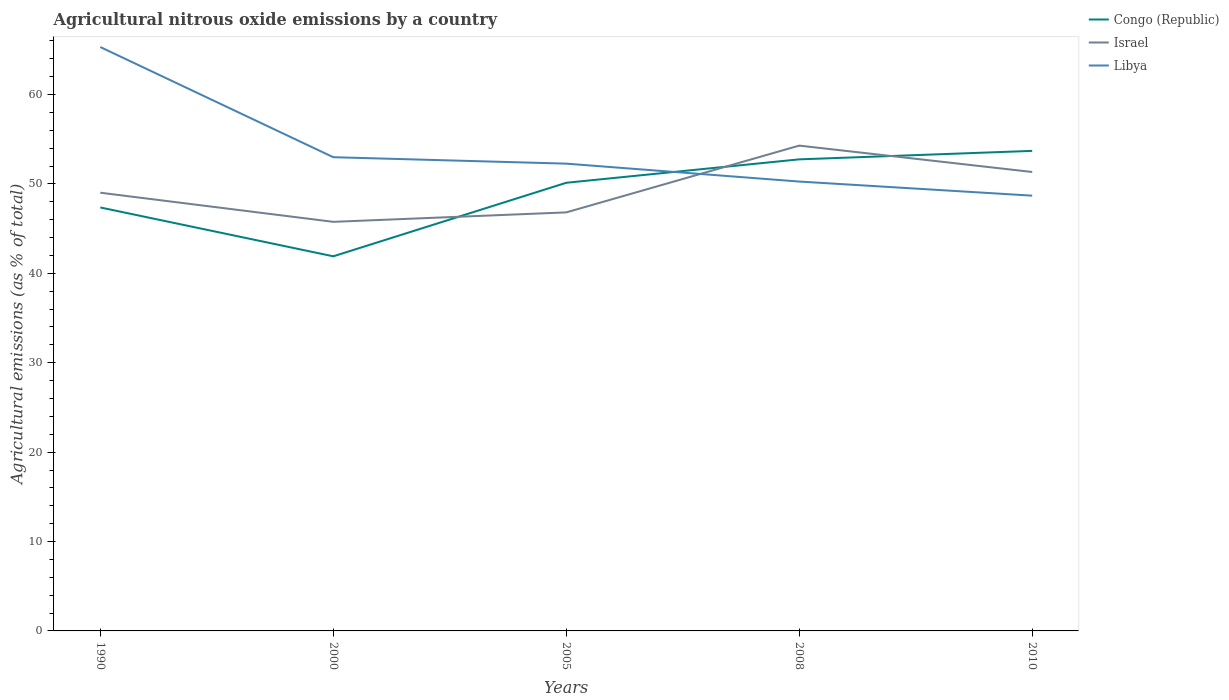How many different coloured lines are there?
Your response must be concise. 3. Does the line corresponding to Congo (Republic) intersect with the line corresponding to Israel?
Your answer should be compact. Yes. Across all years, what is the maximum amount of agricultural nitrous oxide emitted in Libya?
Your response must be concise. 48.69. What is the total amount of agricultural nitrous oxide emitted in Libya in the graph?
Provide a succinct answer. 3.58. What is the difference between the highest and the second highest amount of agricultural nitrous oxide emitted in Libya?
Provide a succinct answer. 16.62. What is the difference between the highest and the lowest amount of agricultural nitrous oxide emitted in Congo (Republic)?
Offer a very short reply. 3. Is the amount of agricultural nitrous oxide emitted in Congo (Republic) strictly greater than the amount of agricultural nitrous oxide emitted in Libya over the years?
Ensure brevity in your answer.  No. How many years are there in the graph?
Provide a short and direct response. 5. What is the difference between two consecutive major ticks on the Y-axis?
Your response must be concise. 10. Are the values on the major ticks of Y-axis written in scientific E-notation?
Provide a succinct answer. No. What is the title of the graph?
Provide a short and direct response. Agricultural nitrous oxide emissions by a country. Does "Northern Mariana Islands" appear as one of the legend labels in the graph?
Offer a terse response. No. What is the label or title of the X-axis?
Offer a very short reply. Years. What is the label or title of the Y-axis?
Offer a very short reply. Agricultural emissions (as % of total). What is the Agricultural emissions (as % of total) in Congo (Republic) in 1990?
Make the answer very short. 47.37. What is the Agricultural emissions (as % of total) in Israel in 1990?
Make the answer very short. 49.02. What is the Agricultural emissions (as % of total) of Libya in 1990?
Your response must be concise. 65.31. What is the Agricultural emissions (as % of total) in Congo (Republic) in 2000?
Your response must be concise. 41.9. What is the Agricultural emissions (as % of total) of Israel in 2000?
Make the answer very short. 45.76. What is the Agricultural emissions (as % of total) of Libya in 2000?
Give a very brief answer. 52.99. What is the Agricultural emissions (as % of total) of Congo (Republic) in 2005?
Give a very brief answer. 50.13. What is the Agricultural emissions (as % of total) in Israel in 2005?
Ensure brevity in your answer.  46.82. What is the Agricultural emissions (as % of total) in Libya in 2005?
Offer a terse response. 52.27. What is the Agricultural emissions (as % of total) in Congo (Republic) in 2008?
Provide a succinct answer. 52.75. What is the Agricultural emissions (as % of total) in Israel in 2008?
Keep it short and to the point. 54.29. What is the Agricultural emissions (as % of total) of Libya in 2008?
Make the answer very short. 50.27. What is the Agricultural emissions (as % of total) in Congo (Republic) in 2010?
Your response must be concise. 53.7. What is the Agricultural emissions (as % of total) of Israel in 2010?
Ensure brevity in your answer.  51.34. What is the Agricultural emissions (as % of total) in Libya in 2010?
Your answer should be compact. 48.69. Across all years, what is the maximum Agricultural emissions (as % of total) in Congo (Republic)?
Provide a succinct answer. 53.7. Across all years, what is the maximum Agricultural emissions (as % of total) of Israel?
Offer a very short reply. 54.29. Across all years, what is the maximum Agricultural emissions (as % of total) of Libya?
Give a very brief answer. 65.31. Across all years, what is the minimum Agricultural emissions (as % of total) of Congo (Republic)?
Your answer should be very brief. 41.9. Across all years, what is the minimum Agricultural emissions (as % of total) of Israel?
Provide a succinct answer. 45.76. Across all years, what is the minimum Agricultural emissions (as % of total) in Libya?
Offer a very short reply. 48.69. What is the total Agricultural emissions (as % of total) in Congo (Republic) in the graph?
Your answer should be compact. 245.85. What is the total Agricultural emissions (as % of total) of Israel in the graph?
Give a very brief answer. 247.22. What is the total Agricultural emissions (as % of total) in Libya in the graph?
Provide a succinct answer. 269.53. What is the difference between the Agricultural emissions (as % of total) of Congo (Republic) in 1990 and that in 2000?
Provide a succinct answer. 5.46. What is the difference between the Agricultural emissions (as % of total) of Israel in 1990 and that in 2000?
Ensure brevity in your answer.  3.26. What is the difference between the Agricultural emissions (as % of total) of Libya in 1990 and that in 2000?
Your response must be concise. 12.32. What is the difference between the Agricultural emissions (as % of total) in Congo (Republic) in 1990 and that in 2005?
Keep it short and to the point. -2.76. What is the difference between the Agricultural emissions (as % of total) of Israel in 1990 and that in 2005?
Provide a succinct answer. 2.2. What is the difference between the Agricultural emissions (as % of total) in Libya in 1990 and that in 2005?
Your response must be concise. 13.04. What is the difference between the Agricultural emissions (as % of total) in Congo (Republic) in 1990 and that in 2008?
Make the answer very short. -5.38. What is the difference between the Agricultural emissions (as % of total) in Israel in 1990 and that in 2008?
Provide a short and direct response. -5.27. What is the difference between the Agricultural emissions (as % of total) of Libya in 1990 and that in 2008?
Your answer should be compact. 15.05. What is the difference between the Agricultural emissions (as % of total) of Congo (Republic) in 1990 and that in 2010?
Give a very brief answer. -6.33. What is the difference between the Agricultural emissions (as % of total) of Israel in 1990 and that in 2010?
Make the answer very short. -2.32. What is the difference between the Agricultural emissions (as % of total) of Libya in 1990 and that in 2010?
Ensure brevity in your answer.  16.62. What is the difference between the Agricultural emissions (as % of total) in Congo (Republic) in 2000 and that in 2005?
Provide a succinct answer. -8.23. What is the difference between the Agricultural emissions (as % of total) of Israel in 2000 and that in 2005?
Give a very brief answer. -1.06. What is the difference between the Agricultural emissions (as % of total) in Libya in 2000 and that in 2005?
Keep it short and to the point. 0.72. What is the difference between the Agricultural emissions (as % of total) of Congo (Republic) in 2000 and that in 2008?
Your answer should be compact. -10.84. What is the difference between the Agricultural emissions (as % of total) in Israel in 2000 and that in 2008?
Your response must be concise. -8.53. What is the difference between the Agricultural emissions (as % of total) in Libya in 2000 and that in 2008?
Your answer should be compact. 2.72. What is the difference between the Agricultural emissions (as % of total) in Congo (Republic) in 2000 and that in 2010?
Offer a very short reply. -11.79. What is the difference between the Agricultural emissions (as % of total) in Israel in 2000 and that in 2010?
Give a very brief answer. -5.58. What is the difference between the Agricultural emissions (as % of total) in Libya in 2000 and that in 2010?
Make the answer very short. 4.3. What is the difference between the Agricultural emissions (as % of total) of Congo (Republic) in 2005 and that in 2008?
Offer a terse response. -2.62. What is the difference between the Agricultural emissions (as % of total) in Israel in 2005 and that in 2008?
Offer a very short reply. -7.47. What is the difference between the Agricultural emissions (as % of total) of Libya in 2005 and that in 2008?
Give a very brief answer. 2. What is the difference between the Agricultural emissions (as % of total) of Congo (Republic) in 2005 and that in 2010?
Offer a terse response. -3.57. What is the difference between the Agricultural emissions (as % of total) of Israel in 2005 and that in 2010?
Ensure brevity in your answer.  -4.52. What is the difference between the Agricultural emissions (as % of total) of Libya in 2005 and that in 2010?
Ensure brevity in your answer.  3.58. What is the difference between the Agricultural emissions (as % of total) in Congo (Republic) in 2008 and that in 2010?
Offer a very short reply. -0.95. What is the difference between the Agricultural emissions (as % of total) in Israel in 2008 and that in 2010?
Give a very brief answer. 2.95. What is the difference between the Agricultural emissions (as % of total) in Libya in 2008 and that in 2010?
Your answer should be compact. 1.58. What is the difference between the Agricultural emissions (as % of total) of Congo (Republic) in 1990 and the Agricultural emissions (as % of total) of Israel in 2000?
Offer a very short reply. 1.61. What is the difference between the Agricultural emissions (as % of total) of Congo (Republic) in 1990 and the Agricultural emissions (as % of total) of Libya in 2000?
Give a very brief answer. -5.62. What is the difference between the Agricultural emissions (as % of total) of Israel in 1990 and the Agricultural emissions (as % of total) of Libya in 2000?
Provide a short and direct response. -3.97. What is the difference between the Agricultural emissions (as % of total) of Congo (Republic) in 1990 and the Agricultural emissions (as % of total) of Israel in 2005?
Offer a terse response. 0.55. What is the difference between the Agricultural emissions (as % of total) of Congo (Republic) in 1990 and the Agricultural emissions (as % of total) of Libya in 2005?
Offer a very short reply. -4.9. What is the difference between the Agricultural emissions (as % of total) in Israel in 1990 and the Agricultural emissions (as % of total) in Libya in 2005?
Keep it short and to the point. -3.25. What is the difference between the Agricultural emissions (as % of total) of Congo (Republic) in 1990 and the Agricultural emissions (as % of total) of Israel in 2008?
Provide a short and direct response. -6.92. What is the difference between the Agricultural emissions (as % of total) in Congo (Republic) in 1990 and the Agricultural emissions (as % of total) in Libya in 2008?
Ensure brevity in your answer.  -2.9. What is the difference between the Agricultural emissions (as % of total) in Israel in 1990 and the Agricultural emissions (as % of total) in Libya in 2008?
Your response must be concise. -1.25. What is the difference between the Agricultural emissions (as % of total) in Congo (Republic) in 1990 and the Agricultural emissions (as % of total) in Israel in 2010?
Keep it short and to the point. -3.97. What is the difference between the Agricultural emissions (as % of total) of Congo (Republic) in 1990 and the Agricultural emissions (as % of total) of Libya in 2010?
Keep it short and to the point. -1.32. What is the difference between the Agricultural emissions (as % of total) of Israel in 1990 and the Agricultural emissions (as % of total) of Libya in 2010?
Ensure brevity in your answer.  0.33. What is the difference between the Agricultural emissions (as % of total) of Congo (Republic) in 2000 and the Agricultural emissions (as % of total) of Israel in 2005?
Provide a short and direct response. -4.91. What is the difference between the Agricultural emissions (as % of total) in Congo (Republic) in 2000 and the Agricultural emissions (as % of total) in Libya in 2005?
Make the answer very short. -10.37. What is the difference between the Agricultural emissions (as % of total) in Israel in 2000 and the Agricultural emissions (as % of total) in Libya in 2005?
Ensure brevity in your answer.  -6.51. What is the difference between the Agricultural emissions (as % of total) of Congo (Republic) in 2000 and the Agricultural emissions (as % of total) of Israel in 2008?
Make the answer very short. -12.38. What is the difference between the Agricultural emissions (as % of total) of Congo (Republic) in 2000 and the Agricultural emissions (as % of total) of Libya in 2008?
Your answer should be very brief. -8.36. What is the difference between the Agricultural emissions (as % of total) of Israel in 2000 and the Agricultural emissions (as % of total) of Libya in 2008?
Keep it short and to the point. -4.51. What is the difference between the Agricultural emissions (as % of total) in Congo (Republic) in 2000 and the Agricultural emissions (as % of total) in Israel in 2010?
Keep it short and to the point. -9.43. What is the difference between the Agricultural emissions (as % of total) in Congo (Republic) in 2000 and the Agricultural emissions (as % of total) in Libya in 2010?
Keep it short and to the point. -6.78. What is the difference between the Agricultural emissions (as % of total) in Israel in 2000 and the Agricultural emissions (as % of total) in Libya in 2010?
Ensure brevity in your answer.  -2.93. What is the difference between the Agricultural emissions (as % of total) in Congo (Republic) in 2005 and the Agricultural emissions (as % of total) in Israel in 2008?
Give a very brief answer. -4.16. What is the difference between the Agricultural emissions (as % of total) in Congo (Republic) in 2005 and the Agricultural emissions (as % of total) in Libya in 2008?
Offer a very short reply. -0.14. What is the difference between the Agricultural emissions (as % of total) in Israel in 2005 and the Agricultural emissions (as % of total) in Libya in 2008?
Provide a short and direct response. -3.45. What is the difference between the Agricultural emissions (as % of total) in Congo (Republic) in 2005 and the Agricultural emissions (as % of total) in Israel in 2010?
Give a very brief answer. -1.21. What is the difference between the Agricultural emissions (as % of total) in Congo (Republic) in 2005 and the Agricultural emissions (as % of total) in Libya in 2010?
Give a very brief answer. 1.44. What is the difference between the Agricultural emissions (as % of total) of Israel in 2005 and the Agricultural emissions (as % of total) of Libya in 2010?
Ensure brevity in your answer.  -1.87. What is the difference between the Agricultural emissions (as % of total) of Congo (Republic) in 2008 and the Agricultural emissions (as % of total) of Israel in 2010?
Offer a very short reply. 1.41. What is the difference between the Agricultural emissions (as % of total) of Congo (Republic) in 2008 and the Agricultural emissions (as % of total) of Libya in 2010?
Keep it short and to the point. 4.06. What is the difference between the Agricultural emissions (as % of total) of Israel in 2008 and the Agricultural emissions (as % of total) of Libya in 2010?
Your answer should be very brief. 5.6. What is the average Agricultural emissions (as % of total) in Congo (Republic) per year?
Your answer should be compact. 49.17. What is the average Agricultural emissions (as % of total) of Israel per year?
Offer a terse response. 49.44. What is the average Agricultural emissions (as % of total) of Libya per year?
Ensure brevity in your answer.  53.91. In the year 1990, what is the difference between the Agricultural emissions (as % of total) of Congo (Republic) and Agricultural emissions (as % of total) of Israel?
Offer a terse response. -1.65. In the year 1990, what is the difference between the Agricultural emissions (as % of total) in Congo (Republic) and Agricultural emissions (as % of total) in Libya?
Offer a terse response. -17.94. In the year 1990, what is the difference between the Agricultural emissions (as % of total) of Israel and Agricultural emissions (as % of total) of Libya?
Your answer should be compact. -16.29. In the year 2000, what is the difference between the Agricultural emissions (as % of total) of Congo (Republic) and Agricultural emissions (as % of total) of Israel?
Offer a terse response. -3.86. In the year 2000, what is the difference between the Agricultural emissions (as % of total) of Congo (Republic) and Agricultural emissions (as % of total) of Libya?
Keep it short and to the point. -11.09. In the year 2000, what is the difference between the Agricultural emissions (as % of total) in Israel and Agricultural emissions (as % of total) in Libya?
Provide a short and direct response. -7.23. In the year 2005, what is the difference between the Agricultural emissions (as % of total) in Congo (Republic) and Agricultural emissions (as % of total) in Israel?
Offer a very short reply. 3.31. In the year 2005, what is the difference between the Agricultural emissions (as % of total) in Congo (Republic) and Agricultural emissions (as % of total) in Libya?
Provide a short and direct response. -2.14. In the year 2005, what is the difference between the Agricultural emissions (as % of total) of Israel and Agricultural emissions (as % of total) of Libya?
Your answer should be compact. -5.45. In the year 2008, what is the difference between the Agricultural emissions (as % of total) of Congo (Republic) and Agricultural emissions (as % of total) of Israel?
Ensure brevity in your answer.  -1.54. In the year 2008, what is the difference between the Agricultural emissions (as % of total) of Congo (Republic) and Agricultural emissions (as % of total) of Libya?
Make the answer very short. 2.48. In the year 2008, what is the difference between the Agricultural emissions (as % of total) of Israel and Agricultural emissions (as % of total) of Libya?
Provide a short and direct response. 4.02. In the year 2010, what is the difference between the Agricultural emissions (as % of total) of Congo (Republic) and Agricultural emissions (as % of total) of Israel?
Offer a very short reply. 2.36. In the year 2010, what is the difference between the Agricultural emissions (as % of total) in Congo (Republic) and Agricultural emissions (as % of total) in Libya?
Provide a short and direct response. 5.01. In the year 2010, what is the difference between the Agricultural emissions (as % of total) of Israel and Agricultural emissions (as % of total) of Libya?
Ensure brevity in your answer.  2.65. What is the ratio of the Agricultural emissions (as % of total) of Congo (Republic) in 1990 to that in 2000?
Provide a short and direct response. 1.13. What is the ratio of the Agricultural emissions (as % of total) in Israel in 1990 to that in 2000?
Give a very brief answer. 1.07. What is the ratio of the Agricultural emissions (as % of total) in Libya in 1990 to that in 2000?
Provide a short and direct response. 1.23. What is the ratio of the Agricultural emissions (as % of total) of Congo (Republic) in 1990 to that in 2005?
Your response must be concise. 0.94. What is the ratio of the Agricultural emissions (as % of total) in Israel in 1990 to that in 2005?
Your answer should be very brief. 1.05. What is the ratio of the Agricultural emissions (as % of total) in Libya in 1990 to that in 2005?
Provide a short and direct response. 1.25. What is the ratio of the Agricultural emissions (as % of total) in Congo (Republic) in 1990 to that in 2008?
Give a very brief answer. 0.9. What is the ratio of the Agricultural emissions (as % of total) of Israel in 1990 to that in 2008?
Offer a very short reply. 0.9. What is the ratio of the Agricultural emissions (as % of total) of Libya in 1990 to that in 2008?
Give a very brief answer. 1.3. What is the ratio of the Agricultural emissions (as % of total) of Congo (Republic) in 1990 to that in 2010?
Keep it short and to the point. 0.88. What is the ratio of the Agricultural emissions (as % of total) of Israel in 1990 to that in 2010?
Make the answer very short. 0.95. What is the ratio of the Agricultural emissions (as % of total) of Libya in 1990 to that in 2010?
Provide a short and direct response. 1.34. What is the ratio of the Agricultural emissions (as % of total) of Congo (Republic) in 2000 to that in 2005?
Ensure brevity in your answer.  0.84. What is the ratio of the Agricultural emissions (as % of total) of Israel in 2000 to that in 2005?
Your response must be concise. 0.98. What is the ratio of the Agricultural emissions (as % of total) in Libya in 2000 to that in 2005?
Keep it short and to the point. 1.01. What is the ratio of the Agricultural emissions (as % of total) in Congo (Republic) in 2000 to that in 2008?
Make the answer very short. 0.79. What is the ratio of the Agricultural emissions (as % of total) of Israel in 2000 to that in 2008?
Your answer should be compact. 0.84. What is the ratio of the Agricultural emissions (as % of total) in Libya in 2000 to that in 2008?
Make the answer very short. 1.05. What is the ratio of the Agricultural emissions (as % of total) of Congo (Republic) in 2000 to that in 2010?
Ensure brevity in your answer.  0.78. What is the ratio of the Agricultural emissions (as % of total) of Israel in 2000 to that in 2010?
Provide a succinct answer. 0.89. What is the ratio of the Agricultural emissions (as % of total) of Libya in 2000 to that in 2010?
Ensure brevity in your answer.  1.09. What is the ratio of the Agricultural emissions (as % of total) in Congo (Republic) in 2005 to that in 2008?
Your answer should be compact. 0.95. What is the ratio of the Agricultural emissions (as % of total) of Israel in 2005 to that in 2008?
Provide a short and direct response. 0.86. What is the ratio of the Agricultural emissions (as % of total) of Libya in 2005 to that in 2008?
Keep it short and to the point. 1.04. What is the ratio of the Agricultural emissions (as % of total) in Congo (Republic) in 2005 to that in 2010?
Your answer should be compact. 0.93. What is the ratio of the Agricultural emissions (as % of total) in Israel in 2005 to that in 2010?
Provide a succinct answer. 0.91. What is the ratio of the Agricultural emissions (as % of total) in Libya in 2005 to that in 2010?
Keep it short and to the point. 1.07. What is the ratio of the Agricultural emissions (as % of total) of Congo (Republic) in 2008 to that in 2010?
Ensure brevity in your answer.  0.98. What is the ratio of the Agricultural emissions (as % of total) in Israel in 2008 to that in 2010?
Keep it short and to the point. 1.06. What is the ratio of the Agricultural emissions (as % of total) of Libya in 2008 to that in 2010?
Offer a very short reply. 1.03. What is the difference between the highest and the second highest Agricultural emissions (as % of total) in Congo (Republic)?
Provide a succinct answer. 0.95. What is the difference between the highest and the second highest Agricultural emissions (as % of total) in Israel?
Provide a short and direct response. 2.95. What is the difference between the highest and the second highest Agricultural emissions (as % of total) of Libya?
Make the answer very short. 12.32. What is the difference between the highest and the lowest Agricultural emissions (as % of total) of Congo (Republic)?
Make the answer very short. 11.79. What is the difference between the highest and the lowest Agricultural emissions (as % of total) of Israel?
Offer a terse response. 8.53. What is the difference between the highest and the lowest Agricultural emissions (as % of total) of Libya?
Make the answer very short. 16.62. 